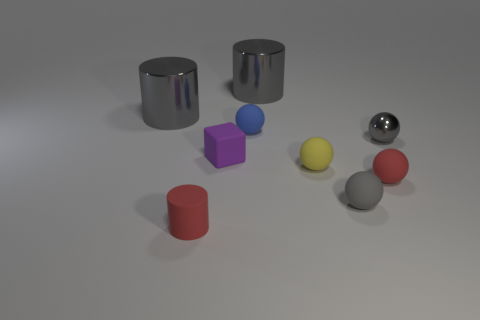Subtract all blue spheres. How many spheres are left? 4 Subtract all small gray matte spheres. How many spheres are left? 4 Subtract all cyan spheres. Subtract all blue blocks. How many spheres are left? 5 Add 1 green objects. How many objects exist? 10 Subtract all cylinders. How many objects are left? 6 Subtract 0 cyan spheres. How many objects are left? 9 Subtract all small gray rubber spheres. Subtract all gray cylinders. How many objects are left? 6 Add 9 tiny purple matte cubes. How many tiny purple matte cubes are left? 10 Add 9 tiny cyan matte balls. How many tiny cyan matte balls exist? 9 